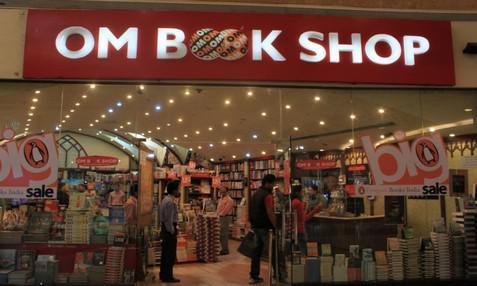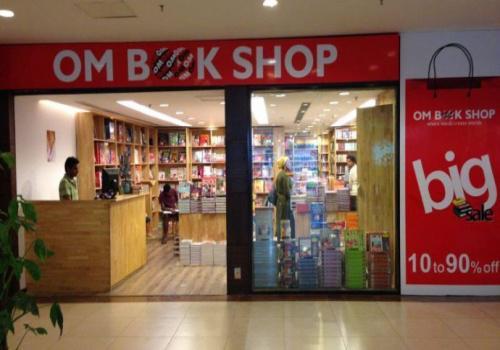The first image is the image on the left, the second image is the image on the right. For the images shown, is this caption "The signage for the store can only be seen in one of the images." true? Answer yes or no. No. The first image is the image on the left, the second image is the image on the right. For the images shown, is this caption "There is no human inside a store in the left image." true? Answer yes or no. No. 